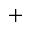<formula> <loc_0><loc_0><loc_500><loc_500>^ { + }</formula> 